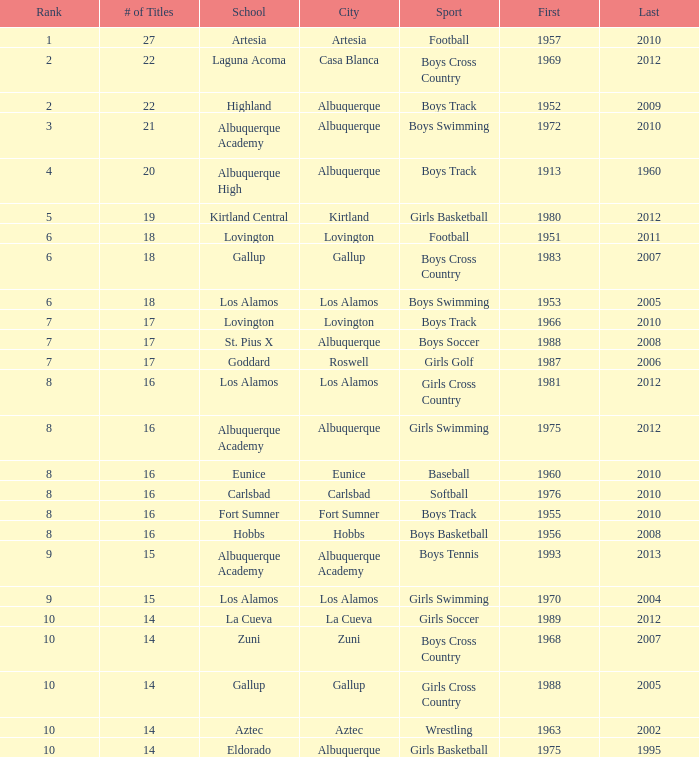What city is the school that had less than 17 titles in boys basketball with the last title being after 2005? Hobbs. 